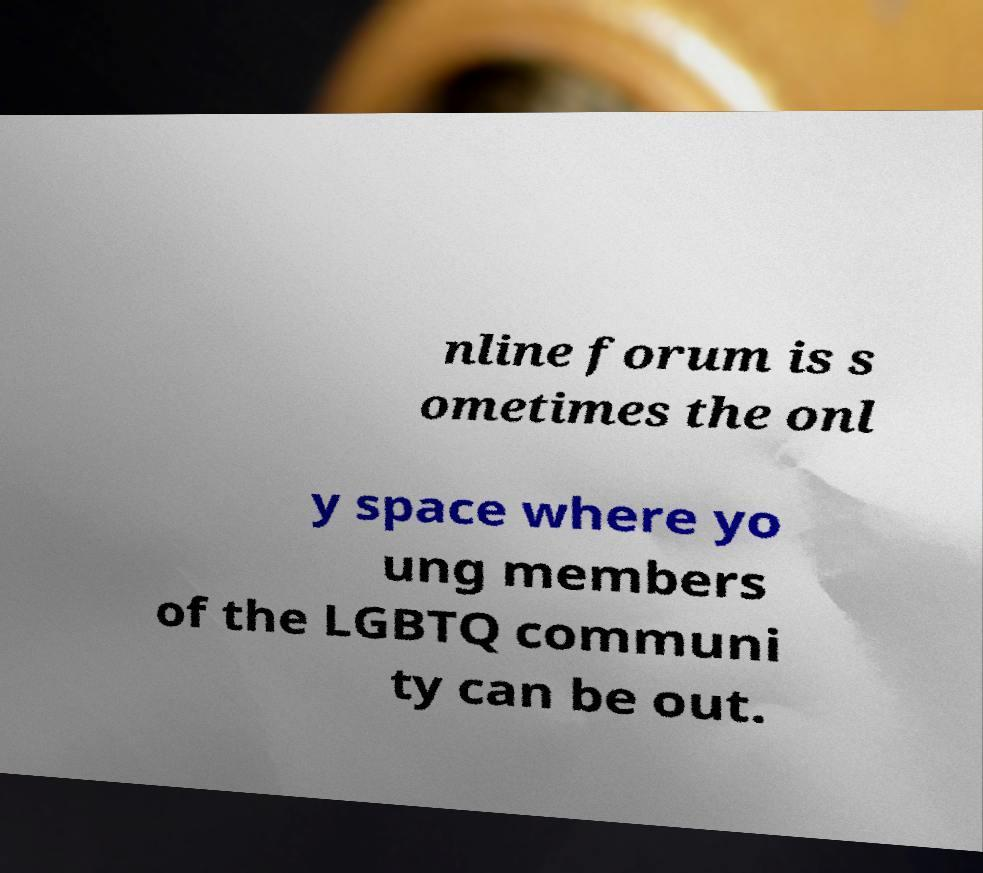Could you extract and type out the text from this image? nline forum is s ometimes the onl y space where yo ung members of the LGBTQ communi ty can be out. 